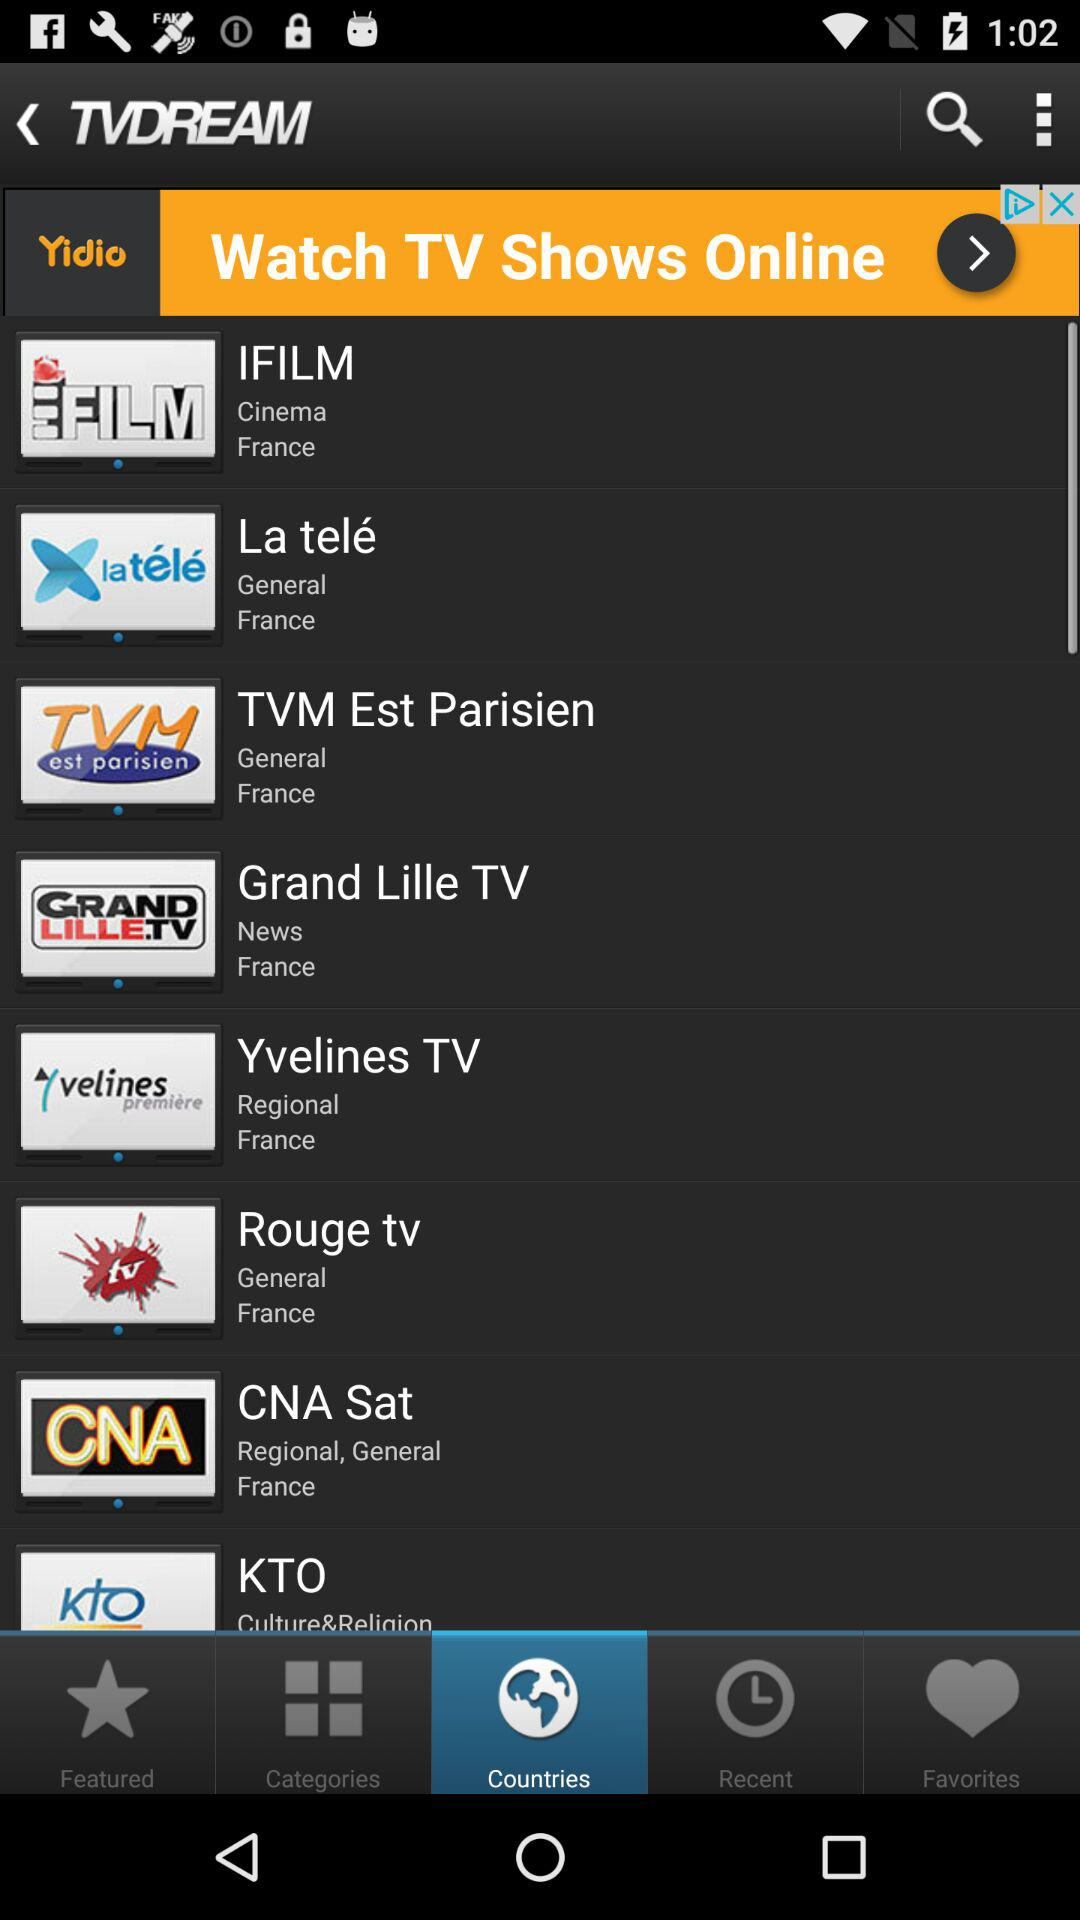What are the cinema channel names? The cinema channel name is "IFILM". 